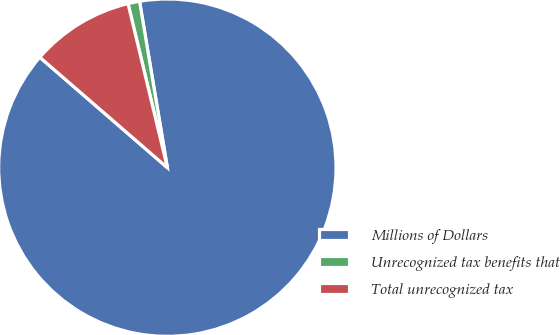<chart> <loc_0><loc_0><loc_500><loc_500><pie_chart><fcel>Millions of Dollars<fcel>Unrecognized tax benefits that<fcel>Total unrecognized tax<nl><fcel>89.0%<fcel>1.11%<fcel>9.9%<nl></chart> 